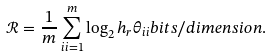<formula> <loc_0><loc_0><loc_500><loc_500>\mathcal { R } & = \frac { 1 } { m } \sum _ { i i = 1 } ^ { m } \log _ { 2 } h _ { r } \theta _ { i i } b i t s / d i m e n s i o n .</formula> 